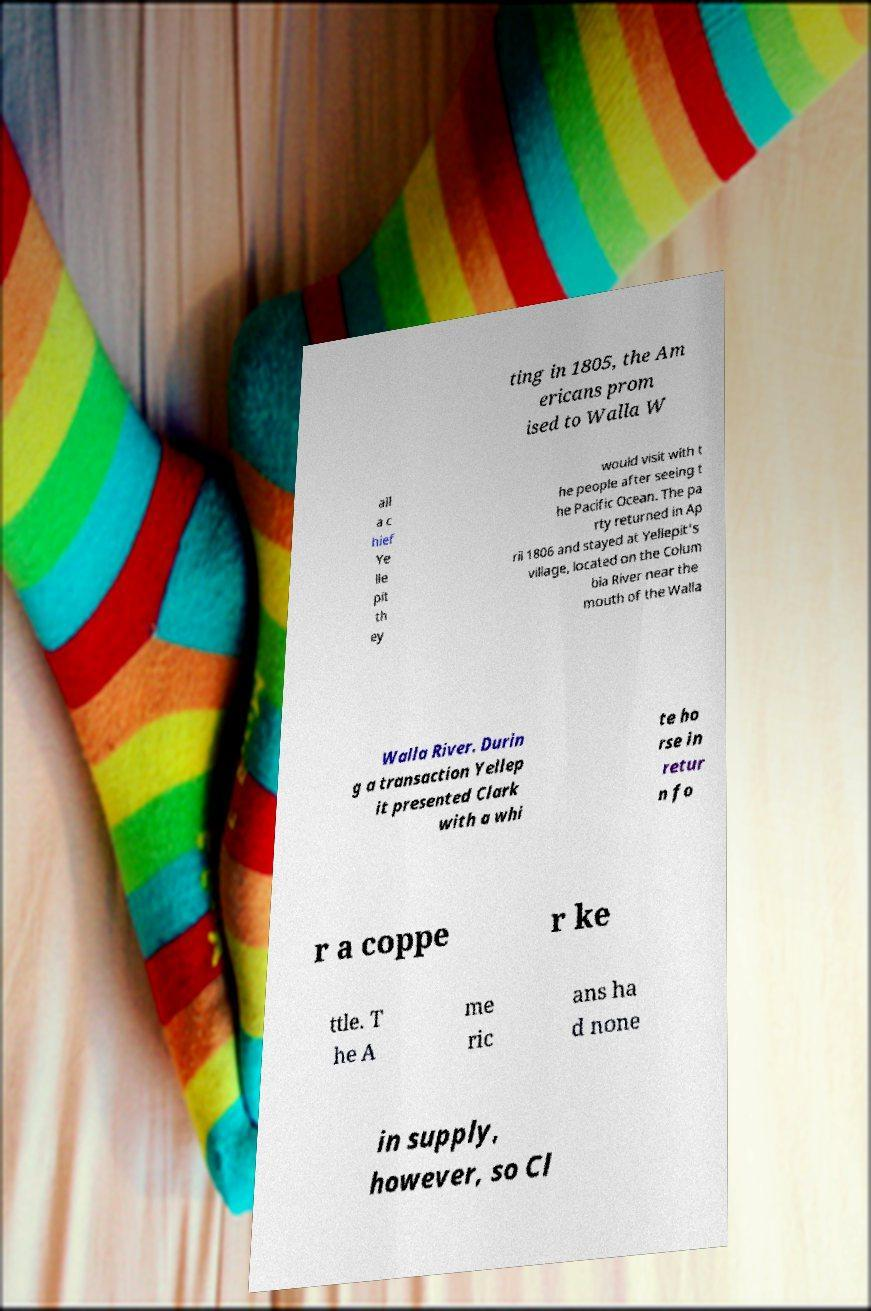What messages or text are displayed in this image? I need them in a readable, typed format. ting in 1805, the Am ericans prom ised to Walla W all a c hief Ye lle pit th ey would visit with t he people after seeing t he Pacific Ocean. The pa rty returned in Ap ril 1806 and stayed at Yellepit's village, located on the Colum bia River near the mouth of the Walla Walla River. Durin g a transaction Yellep it presented Clark with a whi te ho rse in retur n fo r a coppe r ke ttle. T he A me ric ans ha d none in supply, however, so Cl 